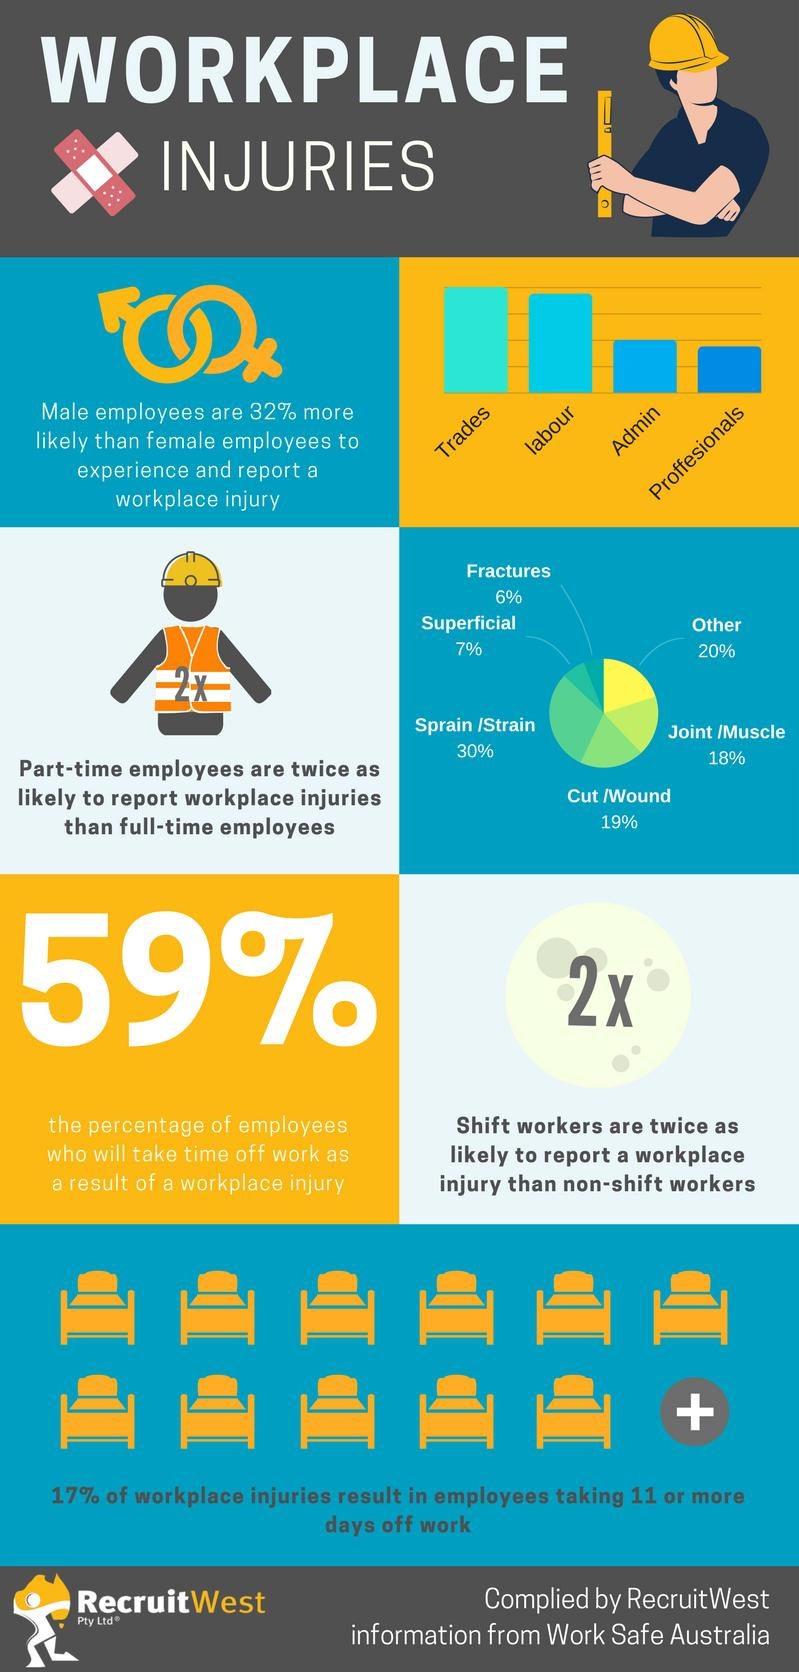Draw attention to some important aspects in this diagram. According to the report, 7% of part-time employees in Australia reported experiencing superficial injuries. Part-time employees in Australia most commonly experience workplace injuries resulting from sprain/strain, according to reported data. The industry that reports a higher frequency of work-related injuries in Australia is trades. A recent study in Australia found that 6% of part-time employees reported having fractures. According to the industry that experiences fewer work-related injuries in Australia, professionals are the ones who report fewer work-related injuries. 